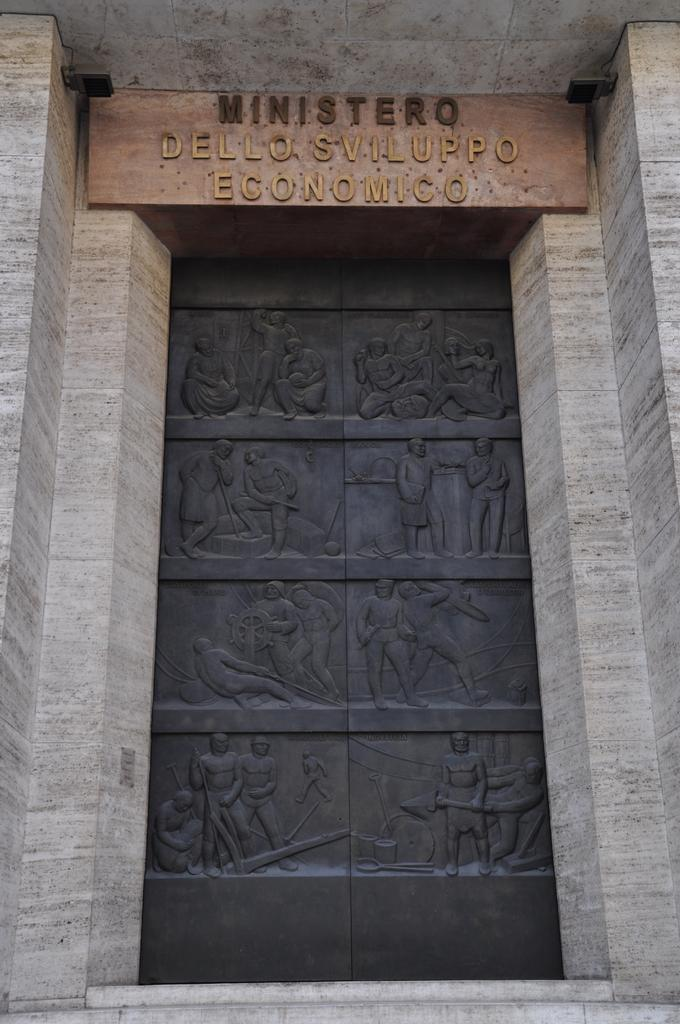What is the main subject in the center of the image? There is a door to a building in the center of the image. What is located at the top of the image? There is a name board at the top of the image. How many sticks are floating in the ocean in the image? There is no ocean or sticks present in the image. 